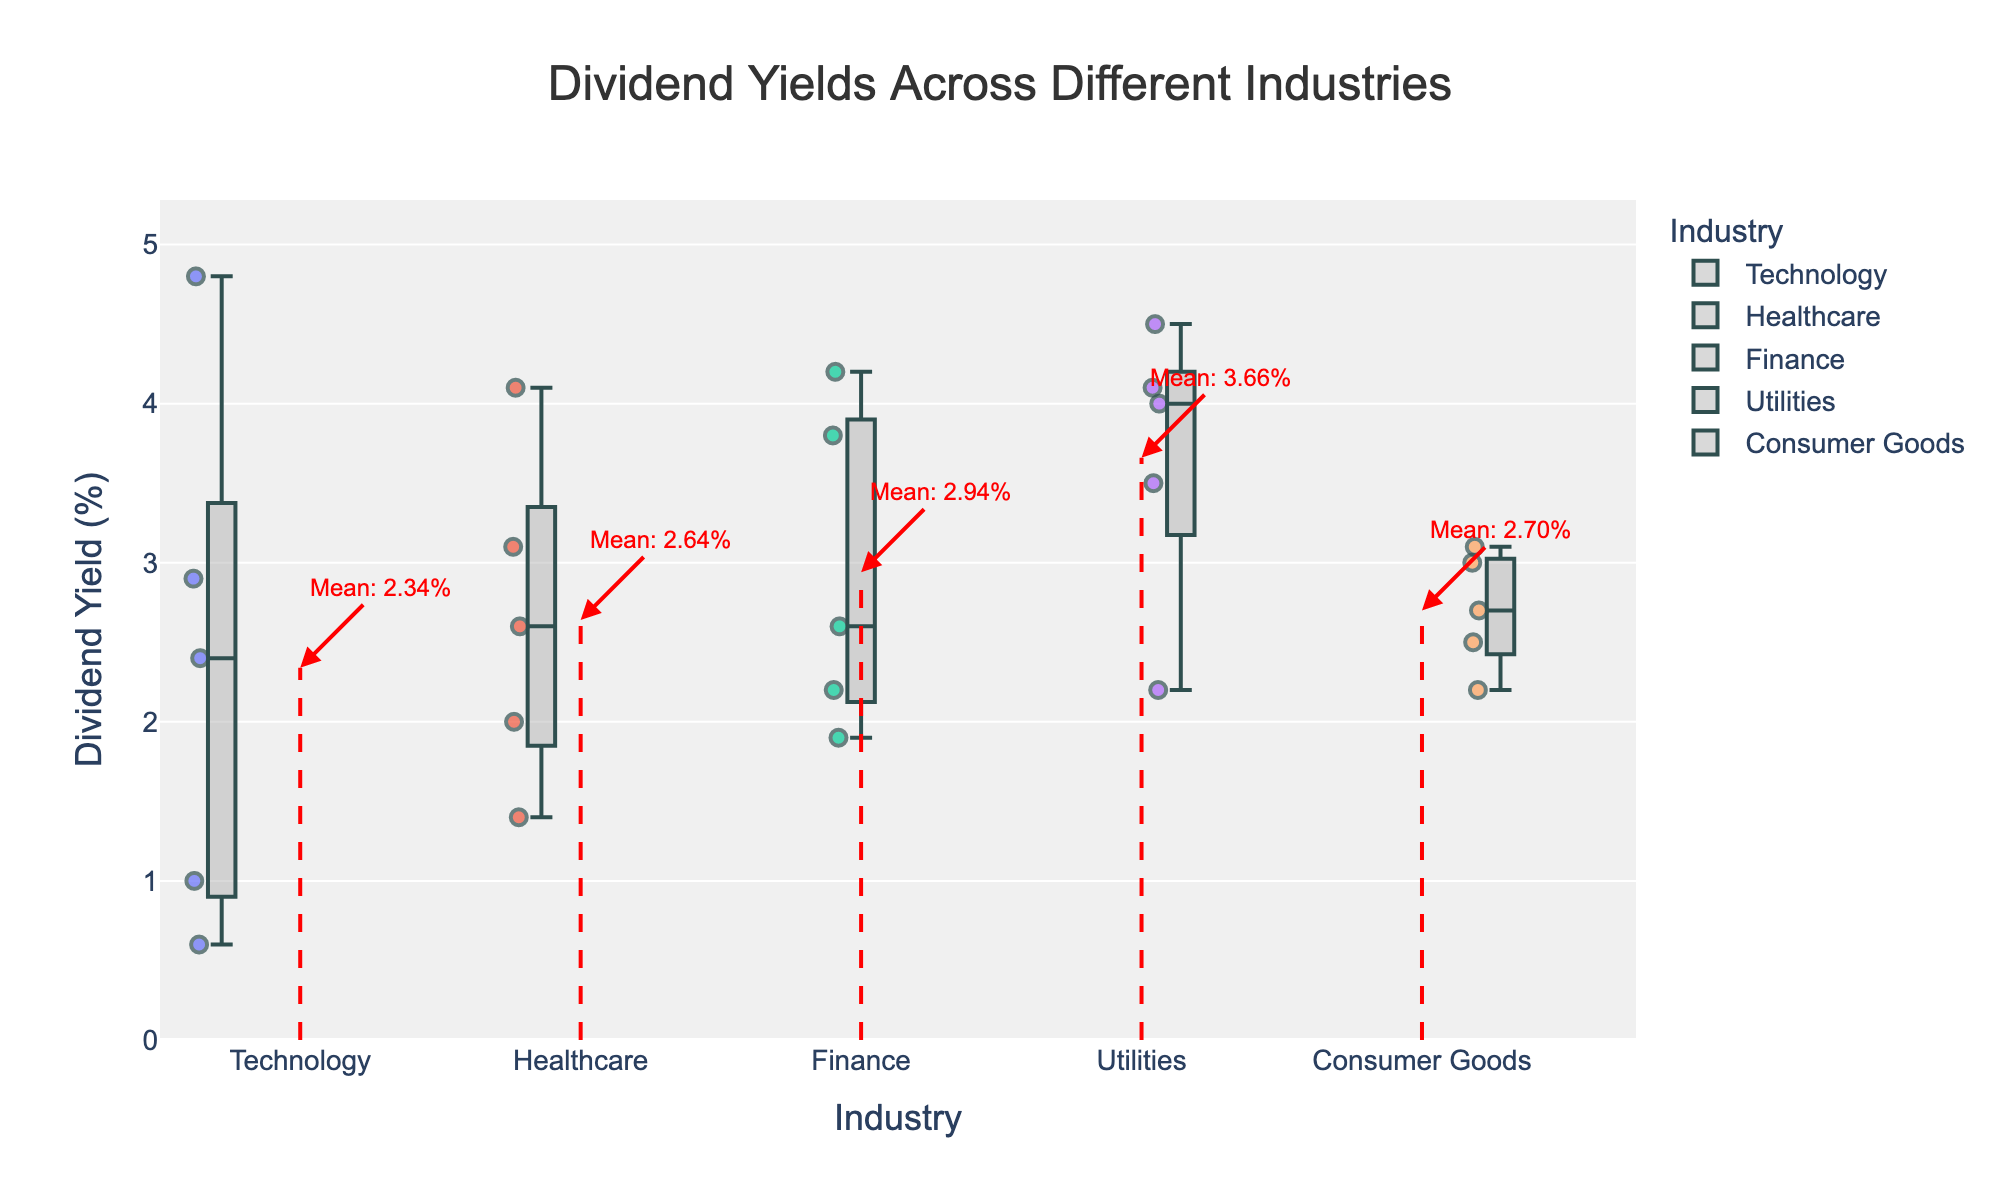what is the title of the plot? The title is usually at the top of the plot and gives an overview of what the visualization is about. Here, it reads "Dividend Yields Across Different Industries" which describes that the plot shows the dividend yields of companies from different industries.
Answer: Dividend Yields Across Different Industries Which industry has the highest median dividend yield? To find the highest median dividend yield, look at the central line inside each box. The industry with the highest central line within its box has the highest median dividend yield.
Answer: Utilities Which company has the highest dividend yield in the Healthcare industry? For this, you would identify the outlier (represented by a point) with the highest value within the Healthcare category. Hovering over points usually provides more information. The highest point represents the company with the highest specific dividend yield.
Answer: Pfizer How many industries have at least one company with a dividend yield above 4%? Look at each box plot and count how many have points or lines that extend above the 4% mark on the y-axis.
Answer: 3 What is the mean dividend yield for the Finance industry? The mean dividend for each industry is indicated by a red dashed line with an annotation next to it. Look for the red dashed line and the associated text in the Finance category.
Answer: 2.94% Which industry has the widest range of dividend yields? The range can be determined by the distance between the top and bottom lines of the whiskers for each box plot. The industry with the largest gap between these two lines has the widest range.
Answer: Technology Which two companies have similar dividend yields in the Technology industry? To find companies with similar dividend yields, look at the points within the Technology industry box. Identify points that are close together in terms of y-axis values and hover over them to see the company names.
Answer: Microsoft and Intel Is there an industry where the mean dividend yield is higher than the highest dividend yield in the Technology industry? Compare the mean (indicated by a red dashed line) of all industries with the highest data point in the Technology industry. Identify if any mean line is above this highest point in Technology.
Answer: Yes, Utilities Compare the median dividend yield in Consumer Goods to that in Healthcare. Which is higher? Look at the median line (middle of the box) for both Consumer Goods and Healthcare. Compare their positions on the y-axis to see which is higher.
Answer: Healthcare 